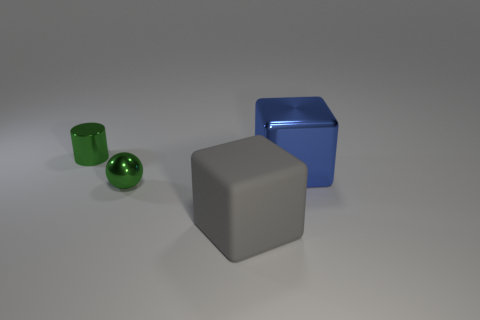Add 2 small red matte objects. How many objects exist? 6 Subtract all balls. How many objects are left? 3 Subtract 0 gray cylinders. How many objects are left? 4 Subtract all metallic cylinders. Subtract all blue objects. How many objects are left? 2 Add 4 green things. How many green things are left? 6 Add 2 gray blocks. How many gray blocks exist? 3 